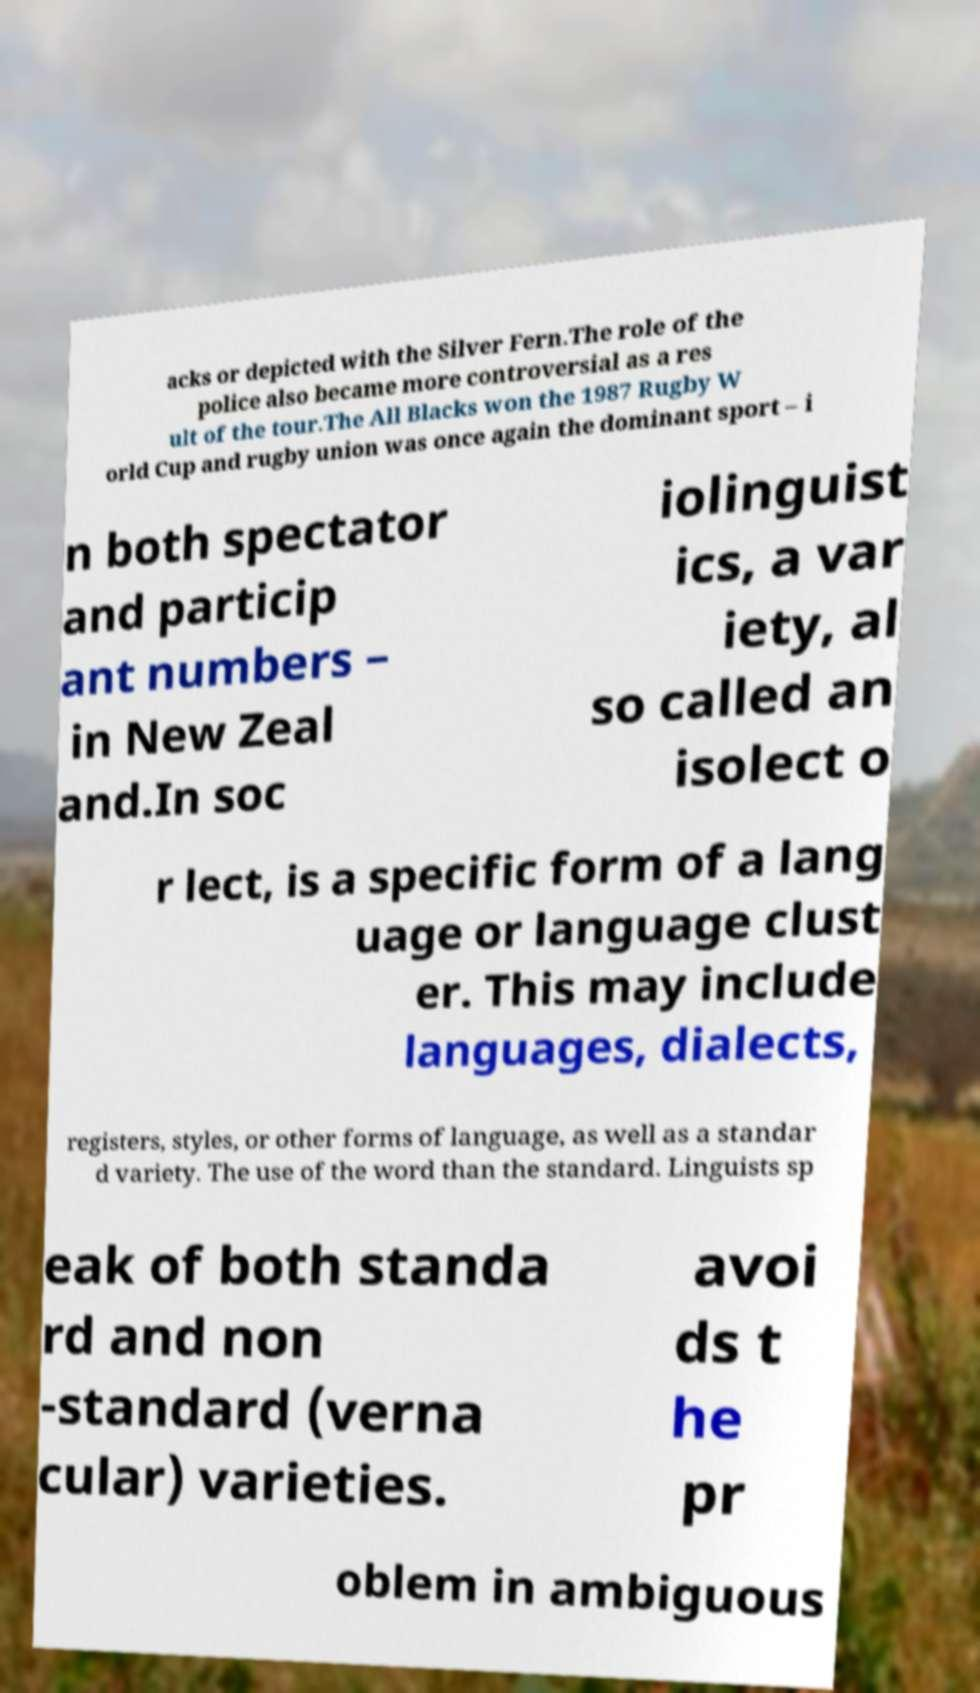There's text embedded in this image that I need extracted. Can you transcribe it verbatim? acks or depicted with the Silver Fern.The role of the police also became more controversial as a res ult of the tour.The All Blacks won the 1987 Rugby W orld Cup and rugby union was once again the dominant sport – i n both spectator and particip ant numbers – in New Zeal and.In soc iolinguist ics, a var iety, al so called an isolect o r lect, is a specific form of a lang uage or language clust er. This may include languages, dialects, registers, styles, or other forms of language, as well as a standar d variety. The use of the word than the standard. Linguists sp eak of both standa rd and non -standard (verna cular) varieties. avoi ds t he pr oblem in ambiguous 